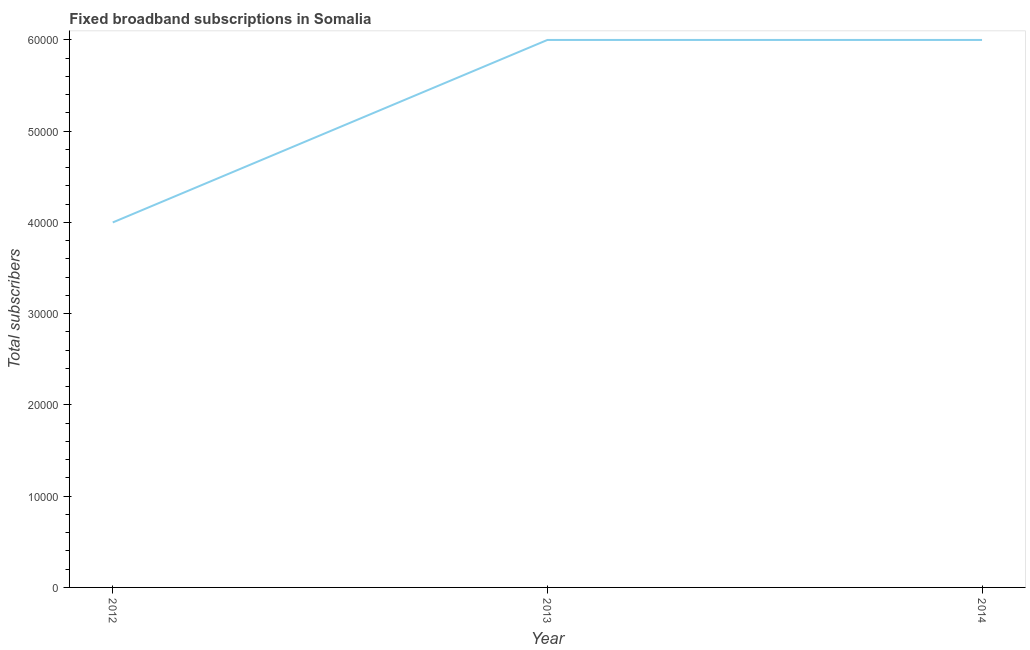What is the total number of fixed broadband subscriptions in 2012?
Provide a succinct answer. 4.00e+04. Across all years, what is the maximum total number of fixed broadband subscriptions?
Your answer should be compact. 6.00e+04. Across all years, what is the minimum total number of fixed broadband subscriptions?
Provide a succinct answer. 4.00e+04. In which year was the total number of fixed broadband subscriptions maximum?
Give a very brief answer. 2013. In which year was the total number of fixed broadband subscriptions minimum?
Your answer should be very brief. 2012. What is the sum of the total number of fixed broadband subscriptions?
Provide a short and direct response. 1.60e+05. What is the difference between the total number of fixed broadband subscriptions in 2012 and 2014?
Provide a short and direct response. -2.00e+04. What is the average total number of fixed broadband subscriptions per year?
Offer a very short reply. 5.33e+04. What is the median total number of fixed broadband subscriptions?
Offer a terse response. 6.00e+04. In how many years, is the total number of fixed broadband subscriptions greater than 52000 ?
Your response must be concise. 2. Do a majority of the years between 2012 and 2014 (inclusive) have total number of fixed broadband subscriptions greater than 8000 ?
Make the answer very short. Yes. What is the ratio of the total number of fixed broadband subscriptions in 2013 to that in 2014?
Keep it short and to the point. 1. What is the difference between the highest and the lowest total number of fixed broadband subscriptions?
Offer a terse response. 2.00e+04. In how many years, is the total number of fixed broadband subscriptions greater than the average total number of fixed broadband subscriptions taken over all years?
Your response must be concise. 2. How many years are there in the graph?
Provide a succinct answer. 3. What is the difference between two consecutive major ticks on the Y-axis?
Provide a short and direct response. 10000. Are the values on the major ticks of Y-axis written in scientific E-notation?
Keep it short and to the point. No. What is the title of the graph?
Your answer should be very brief. Fixed broadband subscriptions in Somalia. What is the label or title of the X-axis?
Provide a succinct answer. Year. What is the label or title of the Y-axis?
Make the answer very short. Total subscribers. What is the Total subscribers of 2012?
Offer a very short reply. 4.00e+04. What is the Total subscribers in 2014?
Provide a short and direct response. 6.00e+04. What is the ratio of the Total subscribers in 2012 to that in 2013?
Offer a very short reply. 0.67. What is the ratio of the Total subscribers in 2012 to that in 2014?
Make the answer very short. 0.67. What is the ratio of the Total subscribers in 2013 to that in 2014?
Make the answer very short. 1. 